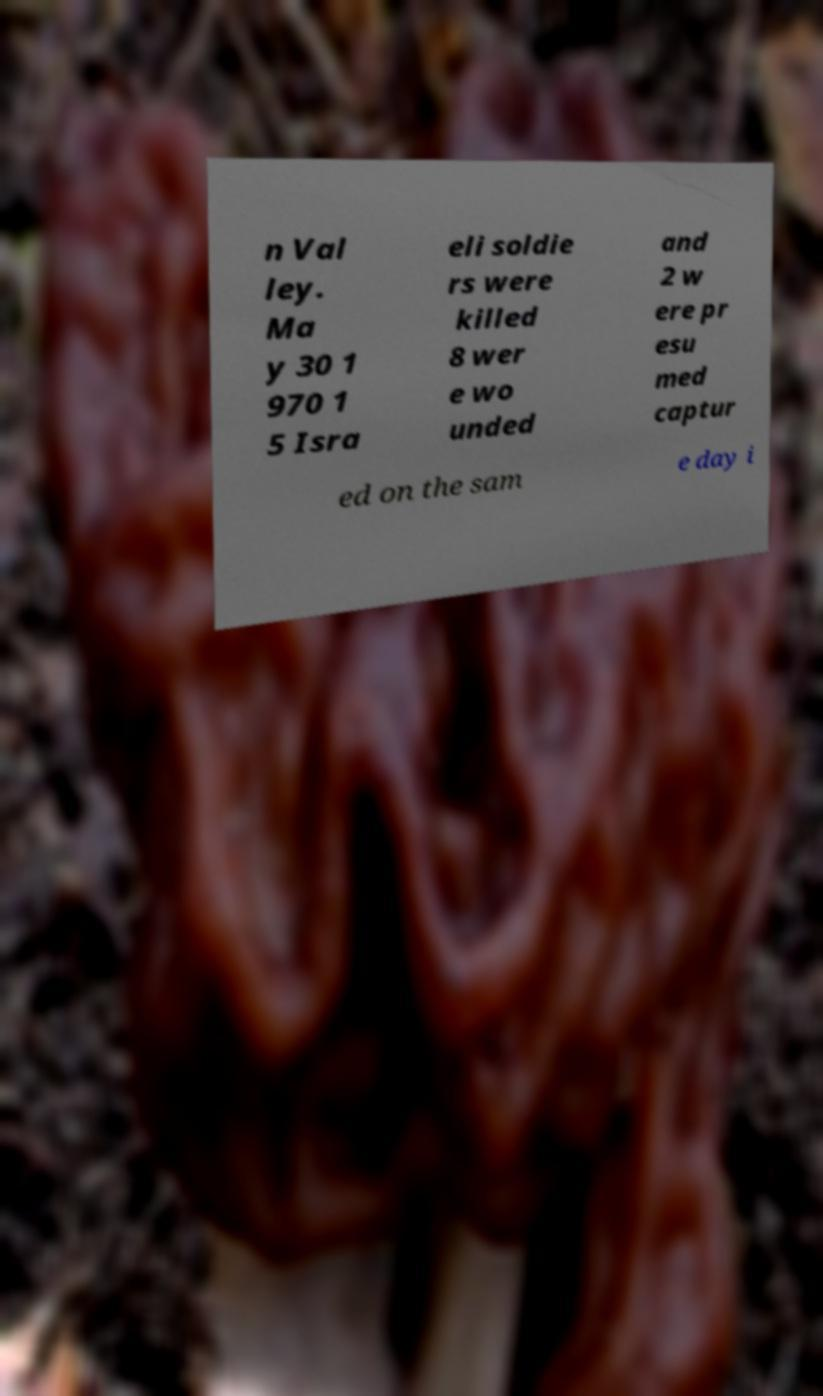I need the written content from this picture converted into text. Can you do that? n Val ley. Ma y 30 1 970 1 5 Isra eli soldie rs were killed 8 wer e wo unded and 2 w ere pr esu med captur ed on the sam e day i 